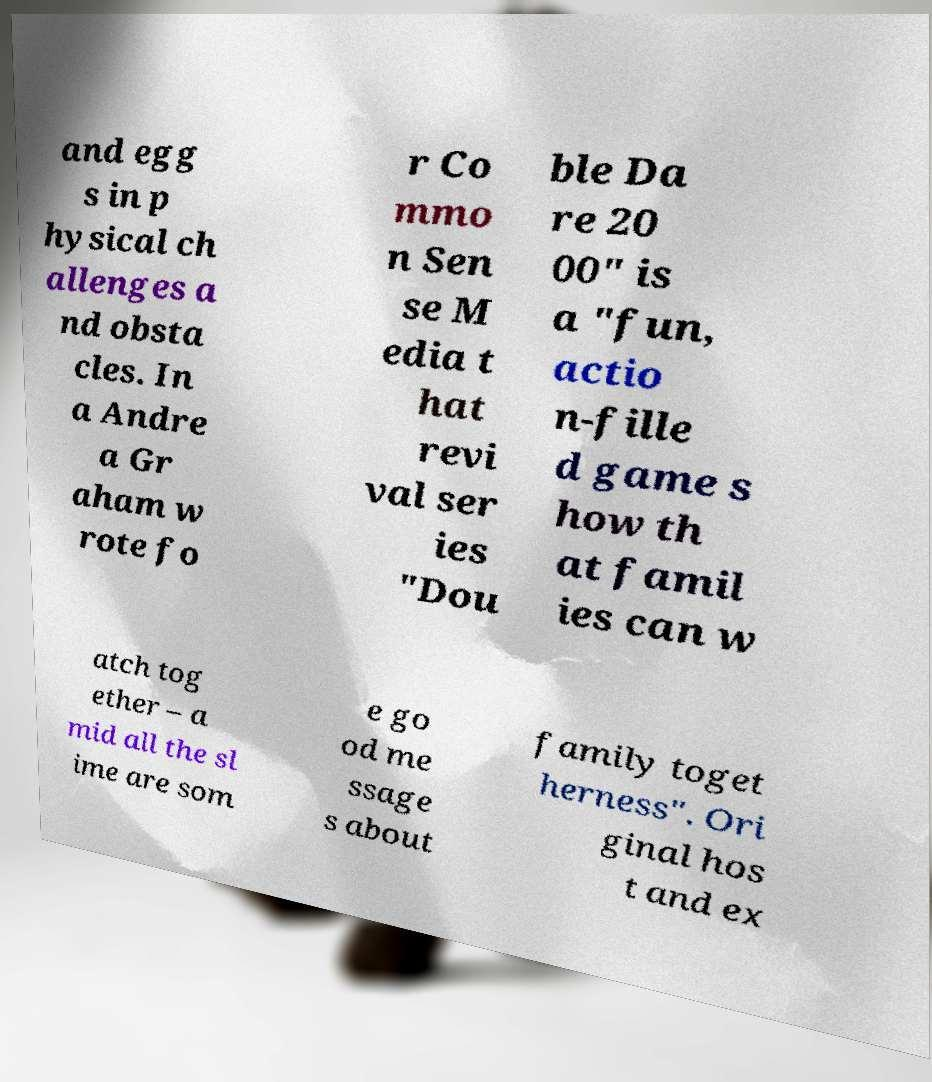Please read and relay the text visible in this image. What does it say? and egg s in p hysical ch allenges a nd obsta cles. In a Andre a Gr aham w rote fo r Co mmo n Sen se M edia t hat revi val ser ies "Dou ble Da re 20 00" is a "fun, actio n-fille d game s how th at famil ies can w atch tog ether – a mid all the sl ime are som e go od me ssage s about family toget herness". Ori ginal hos t and ex 